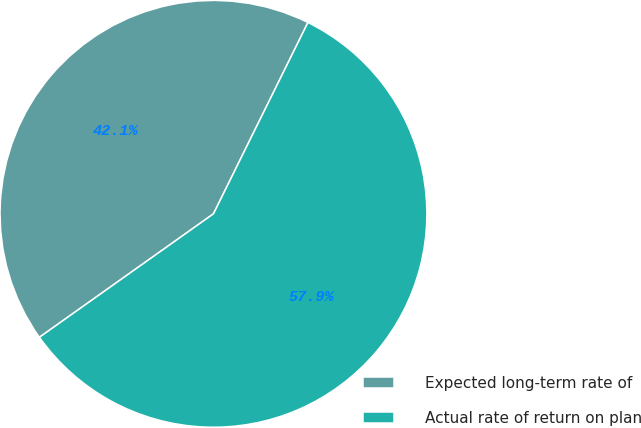Convert chart. <chart><loc_0><loc_0><loc_500><loc_500><pie_chart><fcel>Expected long-term rate of<fcel>Actual rate of return on plan<nl><fcel>42.12%<fcel>57.88%<nl></chart> 